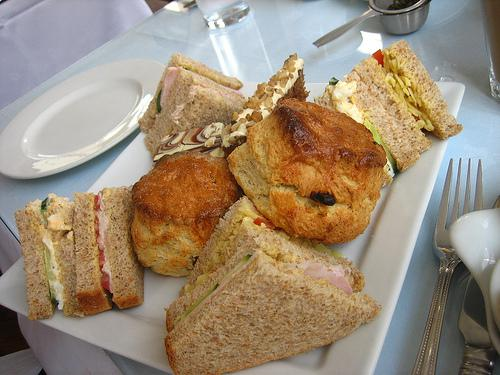Question: who is eating the sandwiches?
Choices:
A. A boy.
B. No one.
C. A girl.
D. The dog.
Answer with the letter. Answer: B Question: what is on the square plate?
Choices:
A. Crackers.
B. Cheese.
C. Grapes.
D. Sandwiches.
Answer with the letter. Answer: D Question: how many sandwiches on the round plate?
Choices:
A. One.
B. Two.
C. Three.
D. None.
Answer with the letter. Answer: D Question: what is the color of the tablecloth?
Choices:
A. White.
B. Blue.
C. Red and white checkered.
D. Yellow.
Answer with the letter. Answer: A 